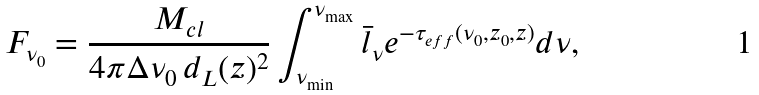Convert formula to latex. <formula><loc_0><loc_0><loc_500><loc_500>F _ { \nu _ { 0 } } = \frac { M _ { c l } } { 4 \pi \Delta \nu _ { 0 } \, d _ { L } ( z ) ^ { 2 } } \int ^ { \nu _ { \max } } _ { \nu _ { \min } } \bar { l } _ { \nu } e ^ { - \tau _ { e f f } ( \nu _ { 0 } , z _ { 0 } , z ) } d \nu ,</formula> 